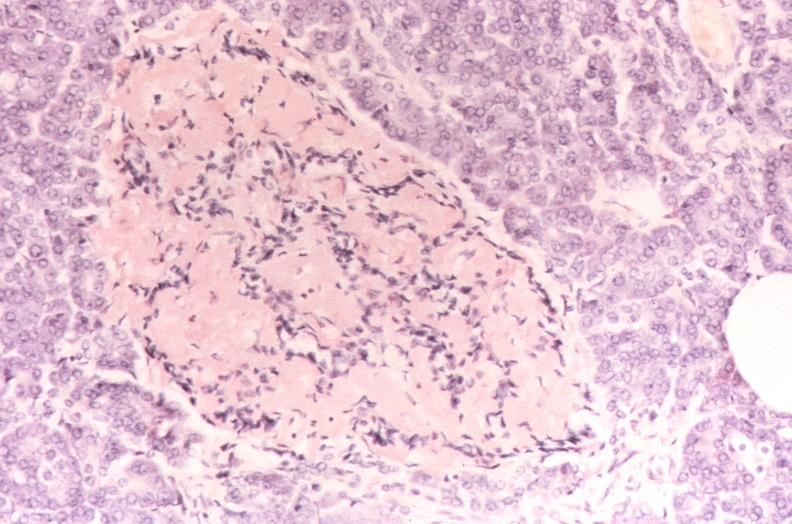what stain?
Answer the question using a single word or phrase. Pancreatic islet 